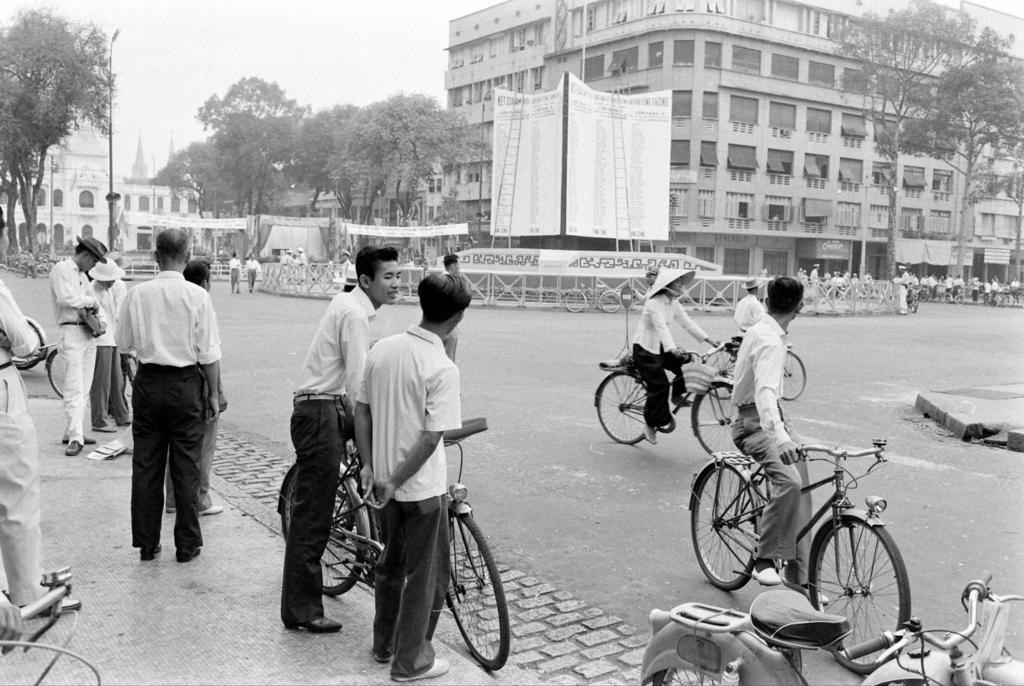Could you give a brief overview of what you see in this image? In this picture there are some people riding a bicycle. Some of them are standing here on the side of the road. In the background there is a poster and some buildings, in front of which trees were present. We can observe a sky in the top left corner here. 